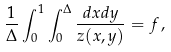<formula> <loc_0><loc_0><loc_500><loc_500>\frac { 1 } { \Delta } \int _ { 0 } ^ { 1 } \int _ { 0 } ^ { \Delta } \frac { d x d y } { z ( x , y ) } = f \, ,</formula> 